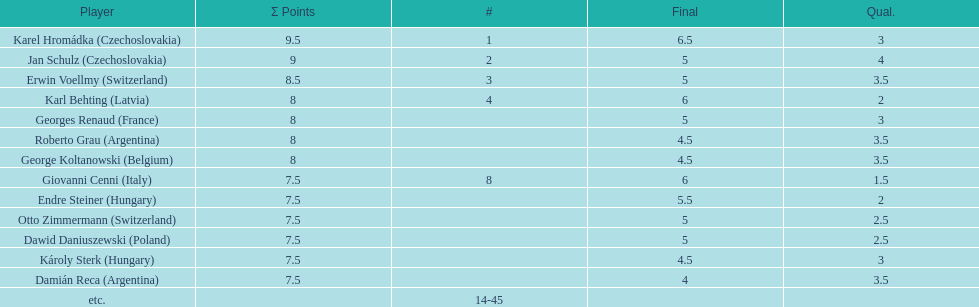Would you be able to parse every entry in this table? {'header': ['Player', 'Σ Points', '#', 'Final', 'Qual.'], 'rows': [['Karel Hromádka\xa0(Czechoslovakia)', '9.5', '1', '6.5', '3'], ['Jan Schulz\xa0(Czechoslovakia)', '9', '2', '5', '4'], ['Erwin Voellmy\xa0(Switzerland)', '8.5', '3', '5', '3.5'], ['Karl Behting\xa0(Latvia)', '8', '4', '6', '2'], ['Georges Renaud\xa0(France)', '8', '', '5', '3'], ['Roberto Grau\xa0(Argentina)', '8', '', '4.5', '3.5'], ['George Koltanowski\xa0(Belgium)', '8', '', '4.5', '3.5'], ['Giovanni Cenni\xa0(Italy)', '7.5', '8', '6', '1.5'], ['Endre Steiner\xa0(Hungary)', '7.5', '', '5.5', '2'], ['Otto Zimmermann\xa0(Switzerland)', '7.5', '', '5', '2.5'], ['Dawid Daniuszewski\xa0(Poland)', '7.5', '', '5', '2.5'], ['Károly Sterk\xa0(Hungary)', '7.5', '', '4.5', '3'], ['Damián Reca\xa0(Argentina)', '7.5', '', '4', '3.5'], ['etc.', '', '14-45', '', '']]} How many countries had more than one player in the consolation cup? 4. 